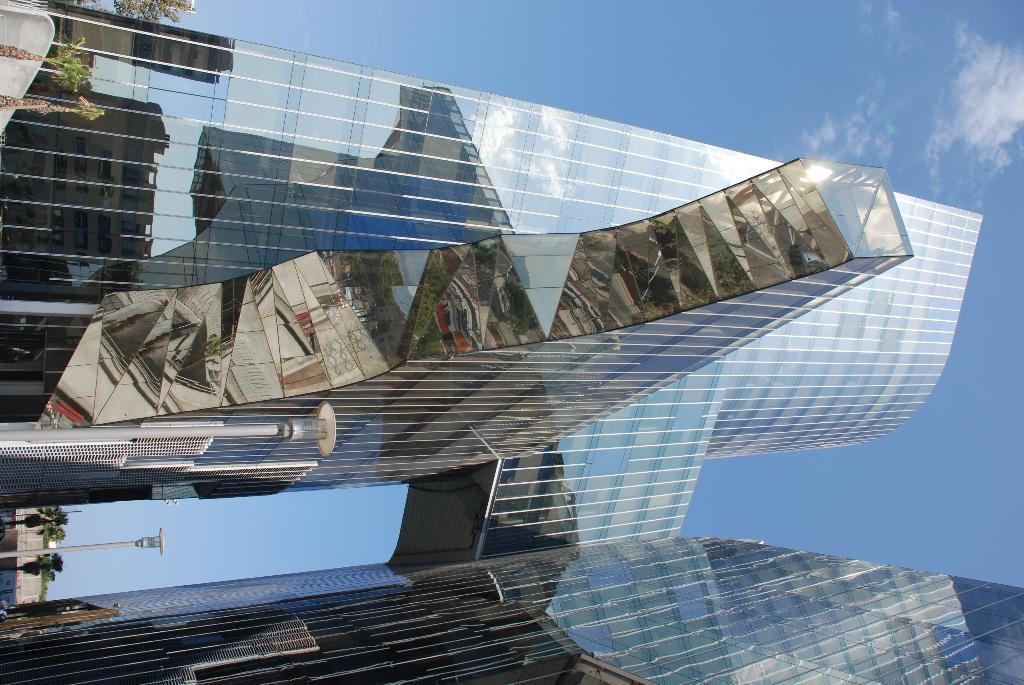What type of structures can be seen in the image? There are buildings in the image. What other natural elements are present in the image? There are trees in the image. Are there any man-made objects besides buildings? Yes, there are poles in the image. What is visible in the sky at the top of the image? There are clouds visible in the sky at the top of the image. What type of health advice can be seen on the umbrella in the image? There is no umbrella present in the image, so no health advice can be seen. Can you tell me the relationship between the father and the buildings in the image? There is no father present in the image, so no relationship can be established between a father and the buildings. 